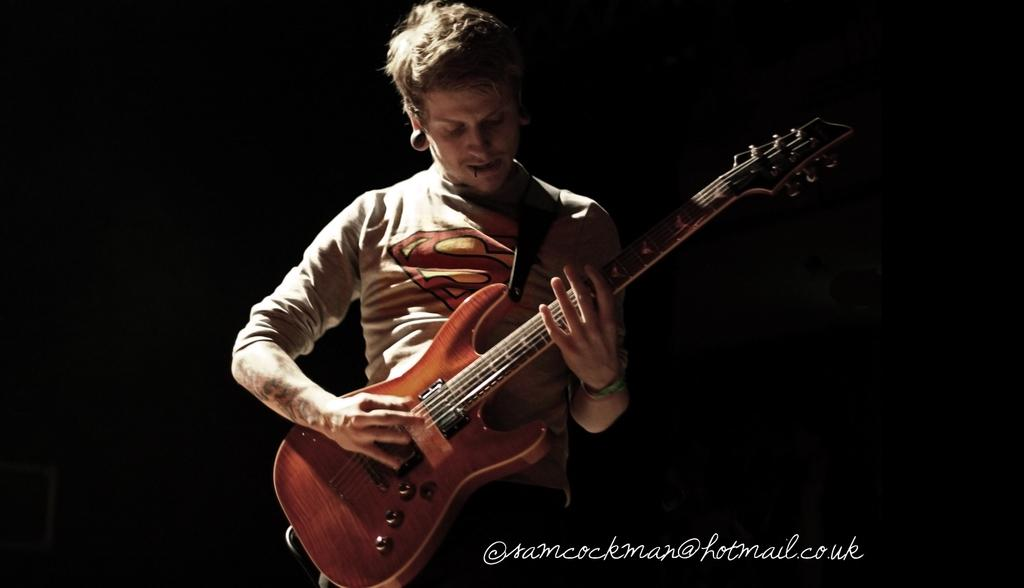What is the main subject of the image? There is a person in the image. What type of clothing is the person wearing? The person is wearing a T-shirt. What activity is the person engaged in? The person is playing a guitar. What type of lock can be seen securing the guitar in the image? There is no lock present in the image, and the guitar is not secured. What type of fire is visible in the image? There is no fire present in the image. 